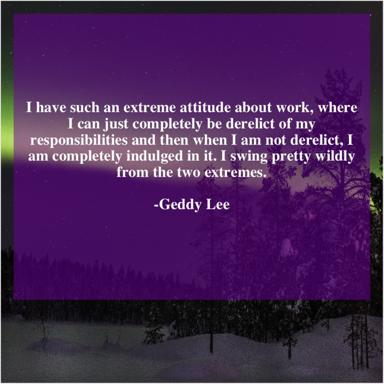What is Geddy Lee's view on work, according to the quote in the image? Geddy Lee reveals a passionate yet erratic approach to work, as indicated in the quote from the image. He admits to oscillating between neglecting his duties and being deeply engaged, reflecting an all-or-nothing work ethic. 